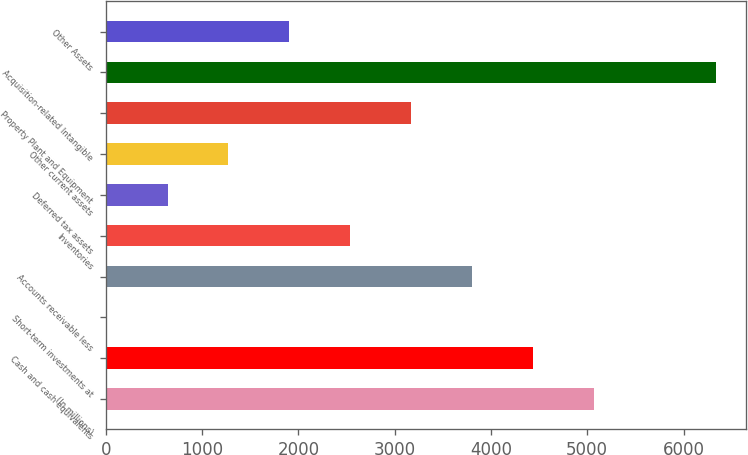<chart> <loc_0><loc_0><loc_500><loc_500><bar_chart><fcel>(In millions)<fcel>Cash and cash equivalents<fcel>Short-term investments at<fcel>Accounts receivable less<fcel>Inventories<fcel>Deferred tax assets<fcel>Other current assets<fcel>Property Plant and Equipment<fcel>Acquisition-related Intangible<fcel>Other Assets<nl><fcel>5071.02<fcel>4438.03<fcel>7.1<fcel>3805.04<fcel>2539.06<fcel>640.09<fcel>1273.08<fcel>3172.05<fcel>6337<fcel>1906.07<nl></chart> 